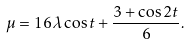Convert formula to latex. <formula><loc_0><loc_0><loc_500><loc_500>\mu = 1 6 \lambda \cos t + \frac { 3 + \cos 2 t } { 6 } .</formula> 